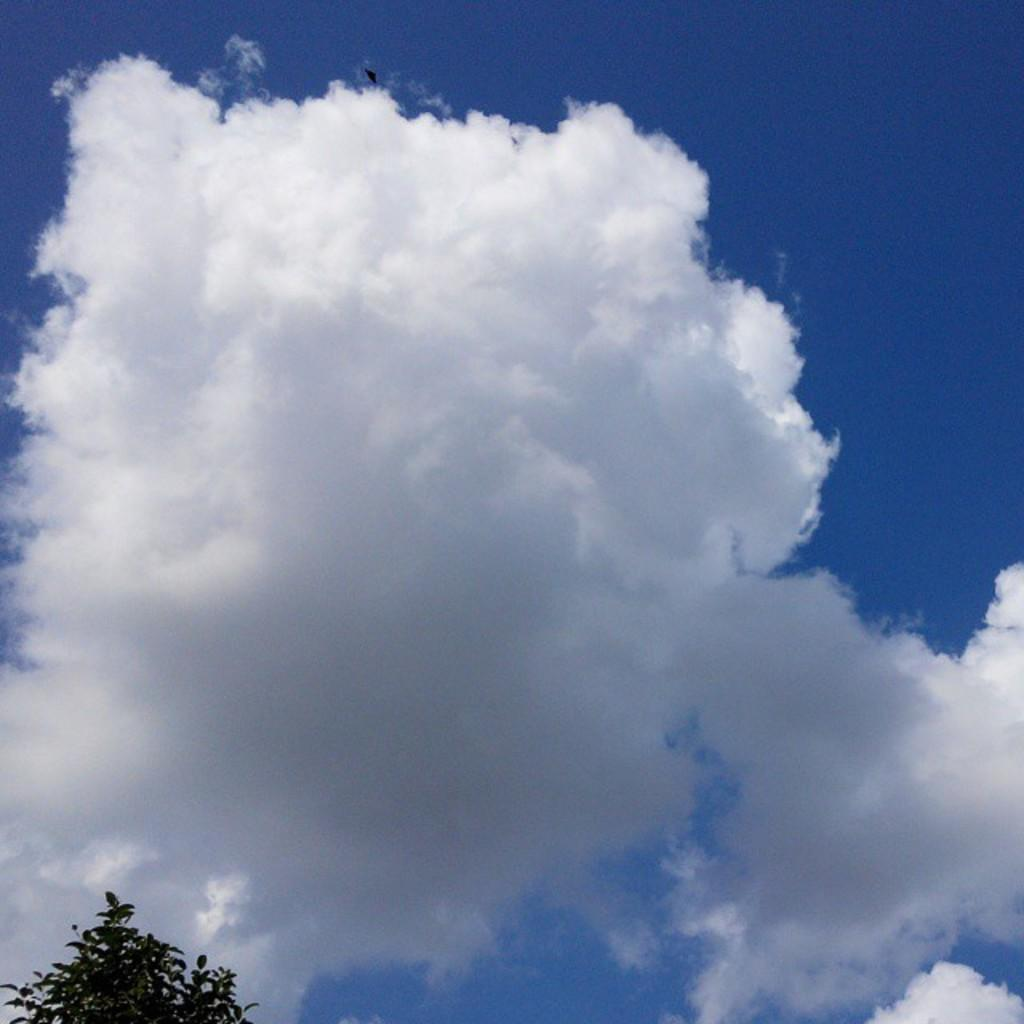What type of plant can be seen in the image? There is a tree in the image. What is visible in the background of the image? The sky is visible in the background of the image. What can be seen in the sky? Clouds are present in the sky. What type of invention is being demonstrated by the women in the image? There are no women or inventions present in the image; it features a tree and clouds in the sky. What type of bread can be seen in the image? There is no bread present in the image. 